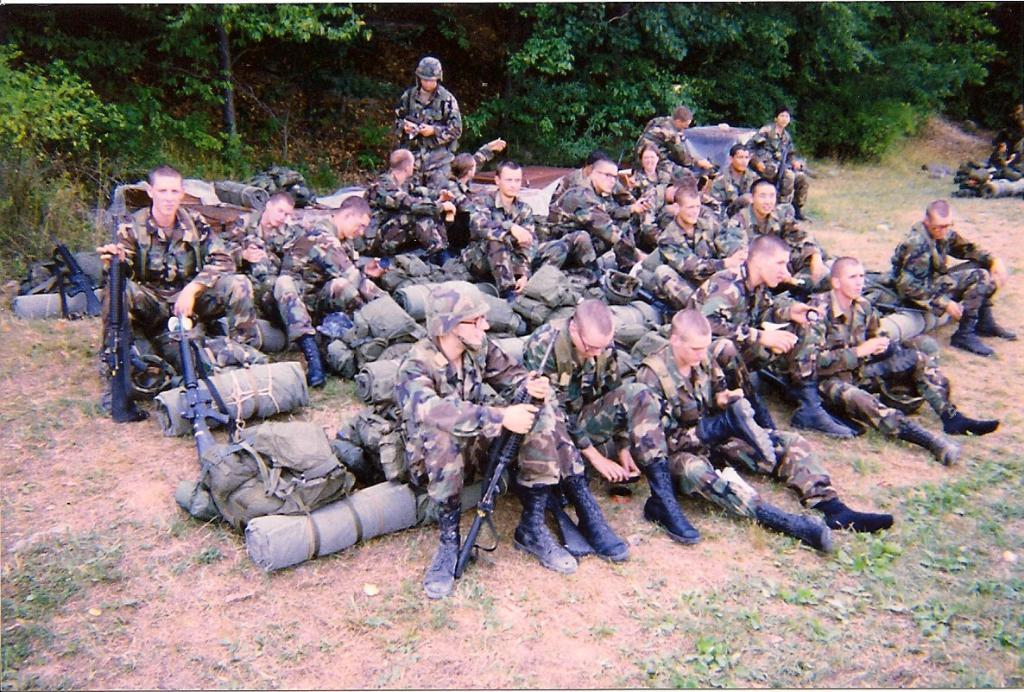How many people are in the image? There is a group of people in the image, but the exact number is not specified. What is on the ground near the people in the image? There are bags and guns on the ground in the image. What can be seen in the background of the image? There are trees in the background of the image. What scientific experiment is being conducted by the ladybug in the image? There is no ladybug present in the image, so no scientific experiment can be observed. 